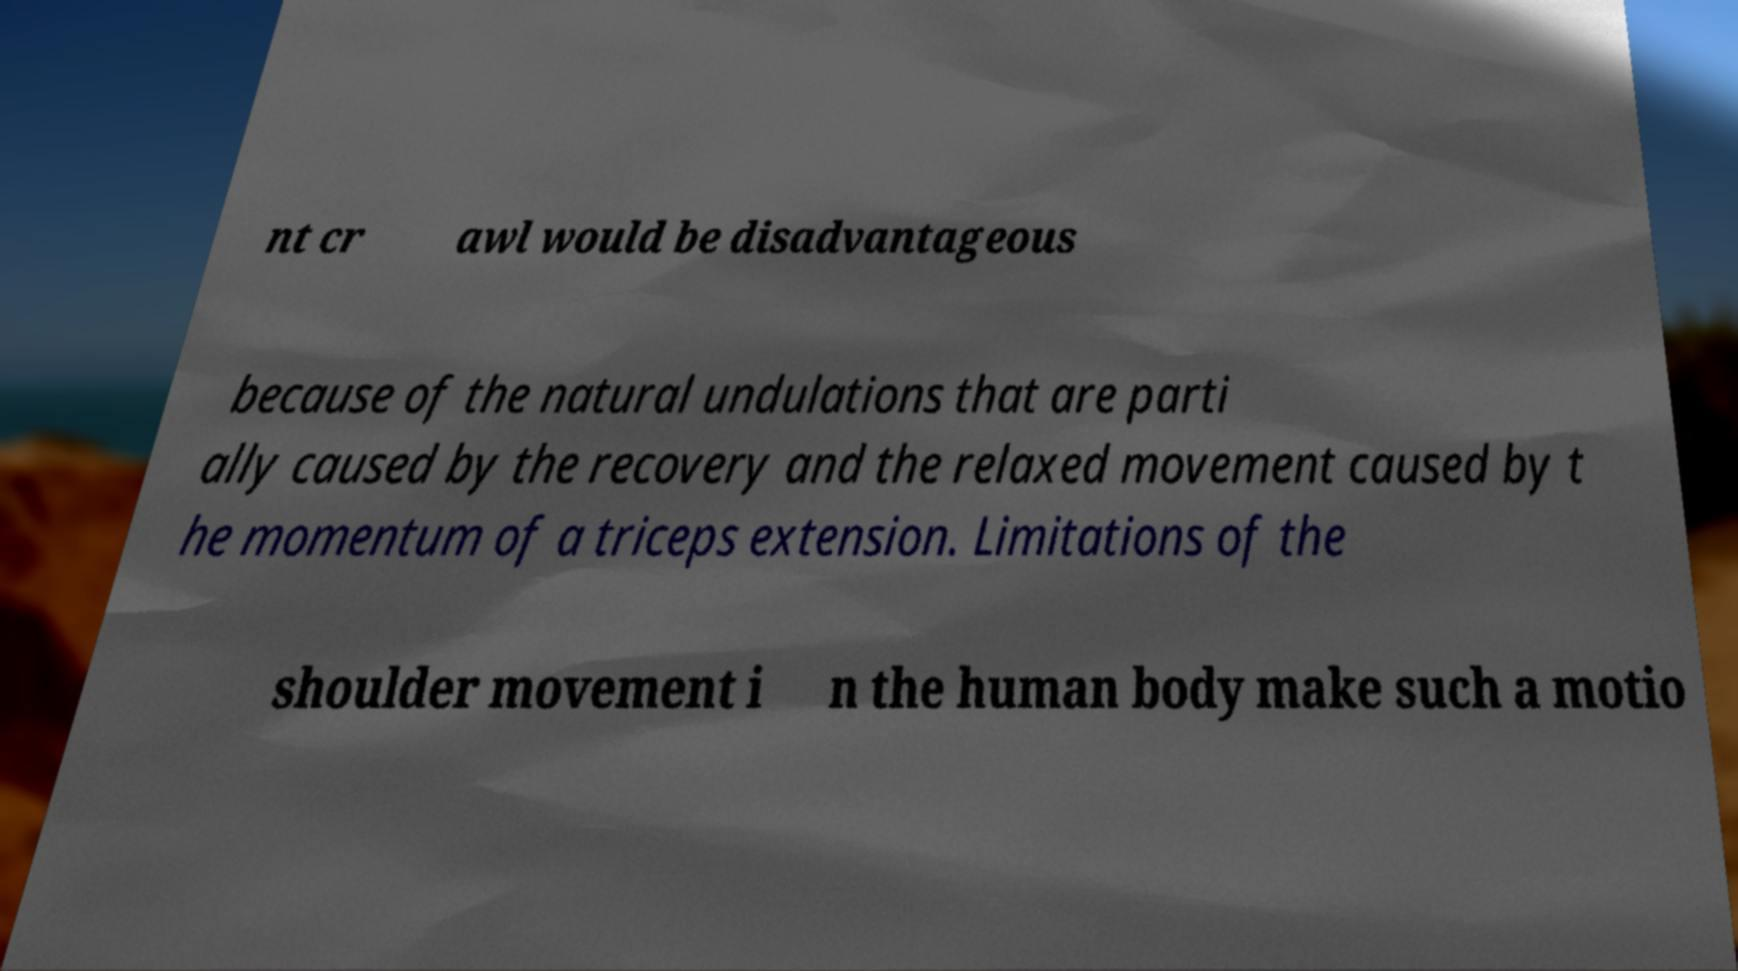What messages or text are displayed in this image? I need them in a readable, typed format. nt cr awl would be disadvantageous because of the natural undulations that are parti ally caused by the recovery and the relaxed movement caused by t he momentum of a triceps extension. Limitations of the shoulder movement i n the human body make such a motio 